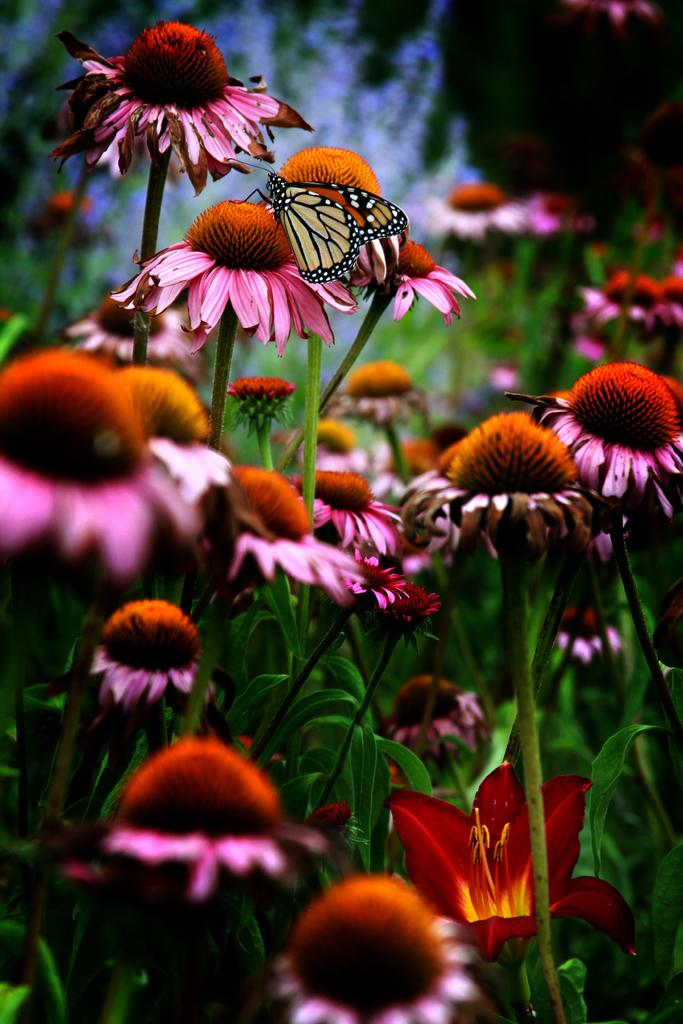What type of living organisms can be seen in the image? There are flowers and a butterfly in the image. Where are the flowers located? The flowers are on plants in the image. What is the butterfly doing in the image? The butterfly is on one of the flowers. What type of quill can be seen in the image? There is no quill present in the image. Is the minister performing a ceremony in the image? There is no minister or ceremony depicted in the image. 